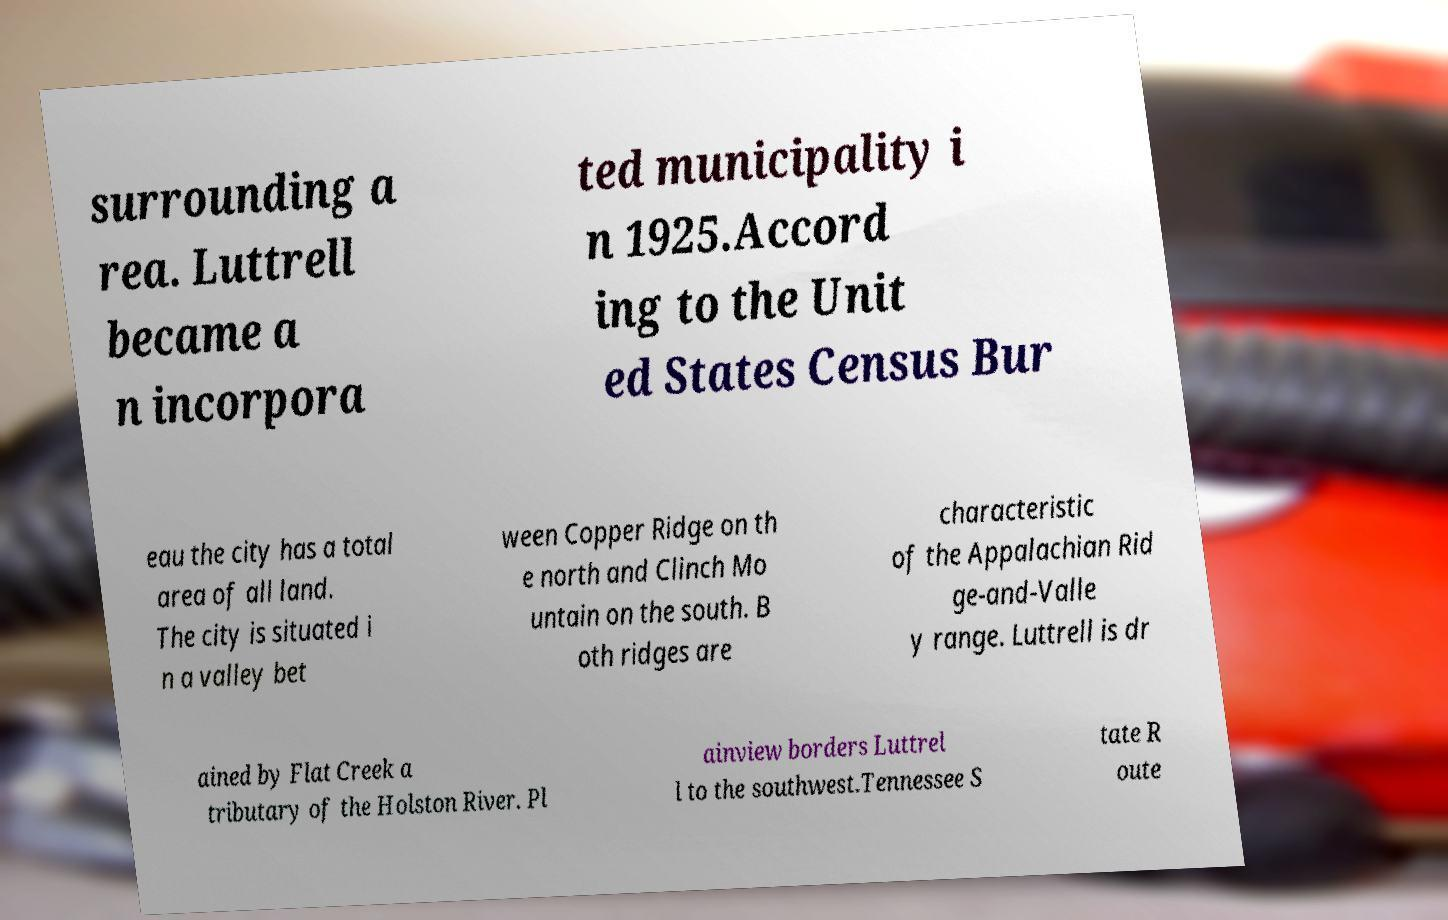Could you assist in decoding the text presented in this image and type it out clearly? surrounding a rea. Luttrell became a n incorpora ted municipality i n 1925.Accord ing to the Unit ed States Census Bur eau the city has a total area of all land. The city is situated i n a valley bet ween Copper Ridge on th e north and Clinch Mo untain on the south. B oth ridges are characteristic of the Appalachian Rid ge-and-Valle y range. Luttrell is dr ained by Flat Creek a tributary of the Holston River. Pl ainview borders Luttrel l to the southwest.Tennessee S tate R oute 